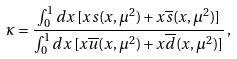<formula> <loc_0><loc_0><loc_500><loc_500>\kappa = \frac { \int _ { 0 } ^ { 1 } d x \, [ x s ( x , \mu ^ { 2 } ) + x \overline { s } ( x , \mu ^ { 2 } ) ] } { \int _ { 0 } ^ { 1 } d x \, [ x \overline { u } ( x , \mu ^ { 2 } ) + x \overline { d } ( x , \mu ^ { 2 } ) ] } \, ,</formula> 